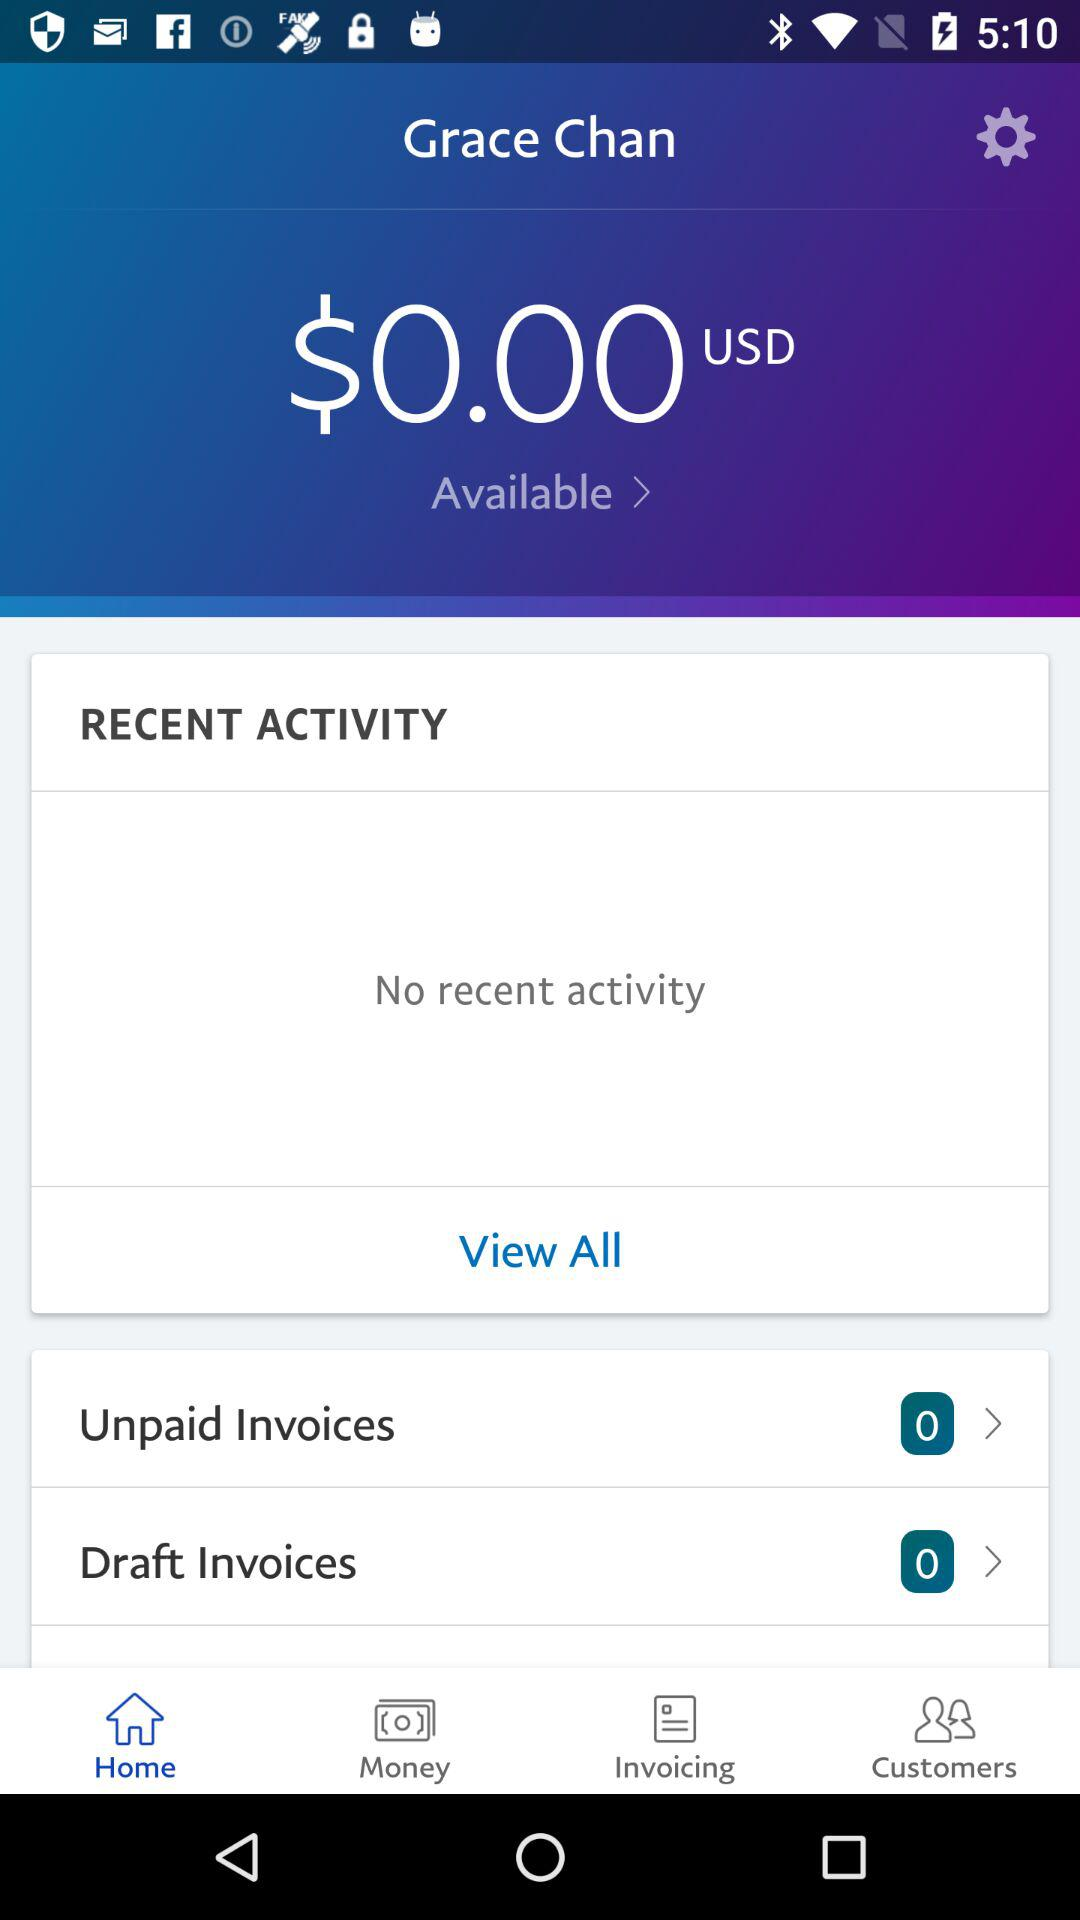How many unpaid invoices are there? There are 0 unpaid invoices. 